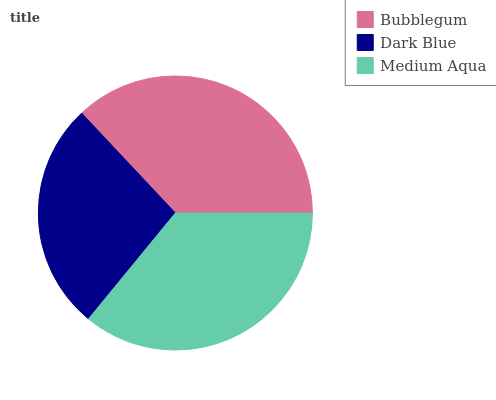Is Dark Blue the minimum?
Answer yes or no. Yes. Is Bubblegum the maximum?
Answer yes or no. Yes. Is Medium Aqua the minimum?
Answer yes or no. No. Is Medium Aqua the maximum?
Answer yes or no. No. Is Medium Aqua greater than Dark Blue?
Answer yes or no. Yes. Is Dark Blue less than Medium Aqua?
Answer yes or no. Yes. Is Dark Blue greater than Medium Aqua?
Answer yes or no. No. Is Medium Aqua less than Dark Blue?
Answer yes or no. No. Is Medium Aqua the high median?
Answer yes or no. Yes. Is Medium Aqua the low median?
Answer yes or no. Yes. Is Bubblegum the high median?
Answer yes or no. No. Is Dark Blue the low median?
Answer yes or no. No. 